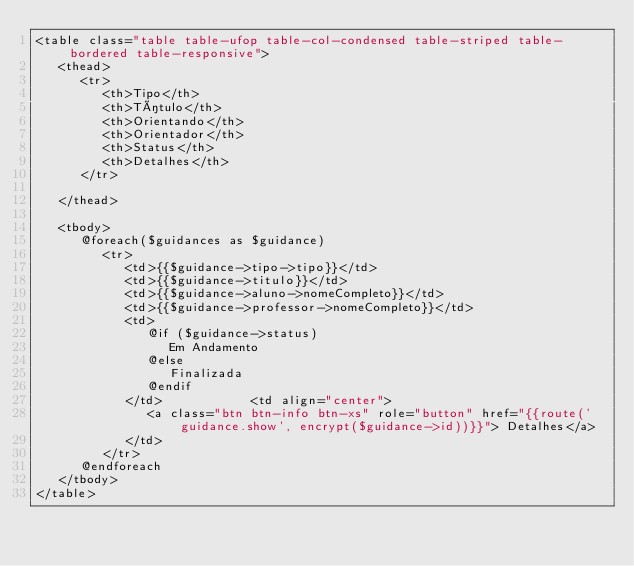Convert code to text. <code><loc_0><loc_0><loc_500><loc_500><_PHP_><table class="table table-ufop table-col-condensed table-striped table-bordered table-responsive">
   <thead>
      <tr>
         <th>Tipo</th>
         <th>Título</th>
         <th>Orientando</th>
         <th>Orientador</th>
         <th>Status</th>
         <th>Detalhes</th>
      </tr>

   </thead>

   <tbody>
      @foreach($guidances as $guidance)
         <tr>
            <td>{{$guidance->tipo->tipo}}</td>
            <td>{{$guidance->titulo}}</td>
            <td>{{$guidance->aluno->nomeCompleto}}</td>
            <td>{{$guidance->professor->nomeCompleto}}</td>
            <td>
               @if ($guidance->status)
                  Em Andamento
               @else
                  Finalizada
               @endif
            </td>            <td align="center">
               <a class="btn btn-info btn-xs" role="button" href="{{route('guidance.show', encrypt($guidance->id))}}"> Detalhes</a>
            </td>
         </tr>
      @endforeach
   </tbody>
</table>
</code> 